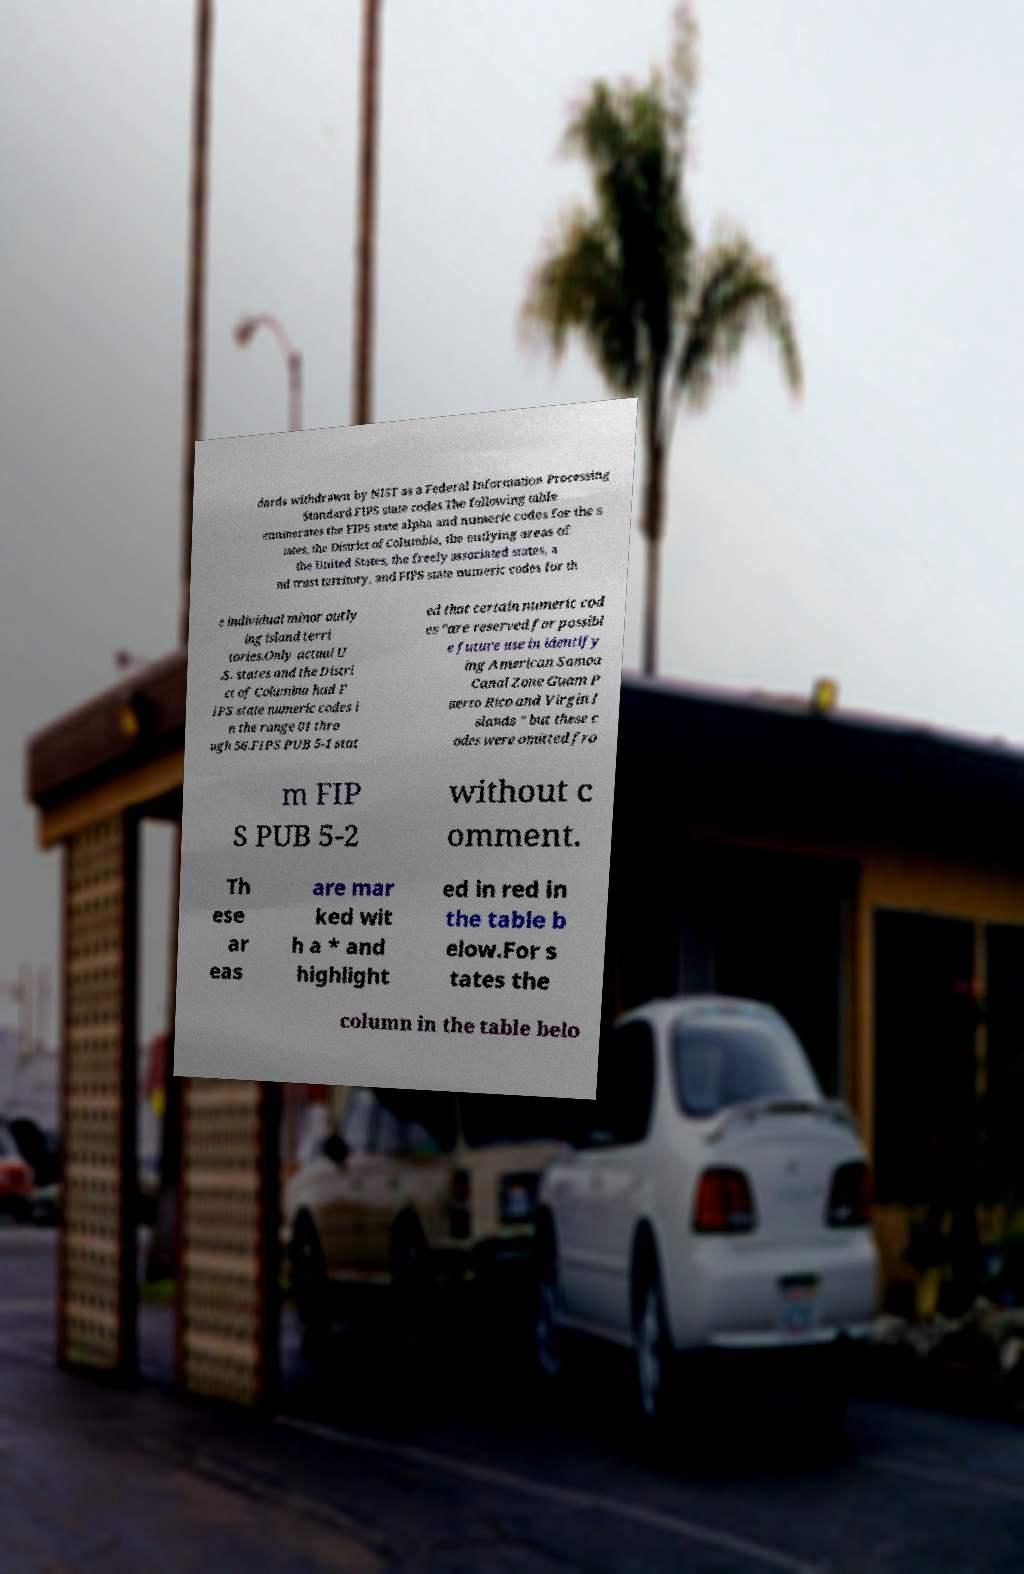For documentation purposes, I need the text within this image transcribed. Could you provide that? dards withdrawn by NIST as a Federal Information Processing Standard.FIPS state codes.The following table enumerates the FIPS state alpha and numeric codes for the s tates, the District of Columbia, the outlying areas of the United States, the freely associated states, a nd trust territory, and FIPS state numeric codes for th e individual minor outly ing island terri tories.Only actual U .S. states and the Distri ct of Columbia had F IPS state numeric codes i n the range 01 thro ugh 56.FIPS PUB 5-1 stat ed that certain numeric cod es "are reserved for possibl e future use in identify ing American Samoa Canal Zone Guam P uerto Rico and Virgin I slands " but these c odes were omitted fro m FIP S PUB 5-2 without c omment. Th ese ar eas are mar ked wit h a * and highlight ed in red in the table b elow.For s tates the column in the table belo 